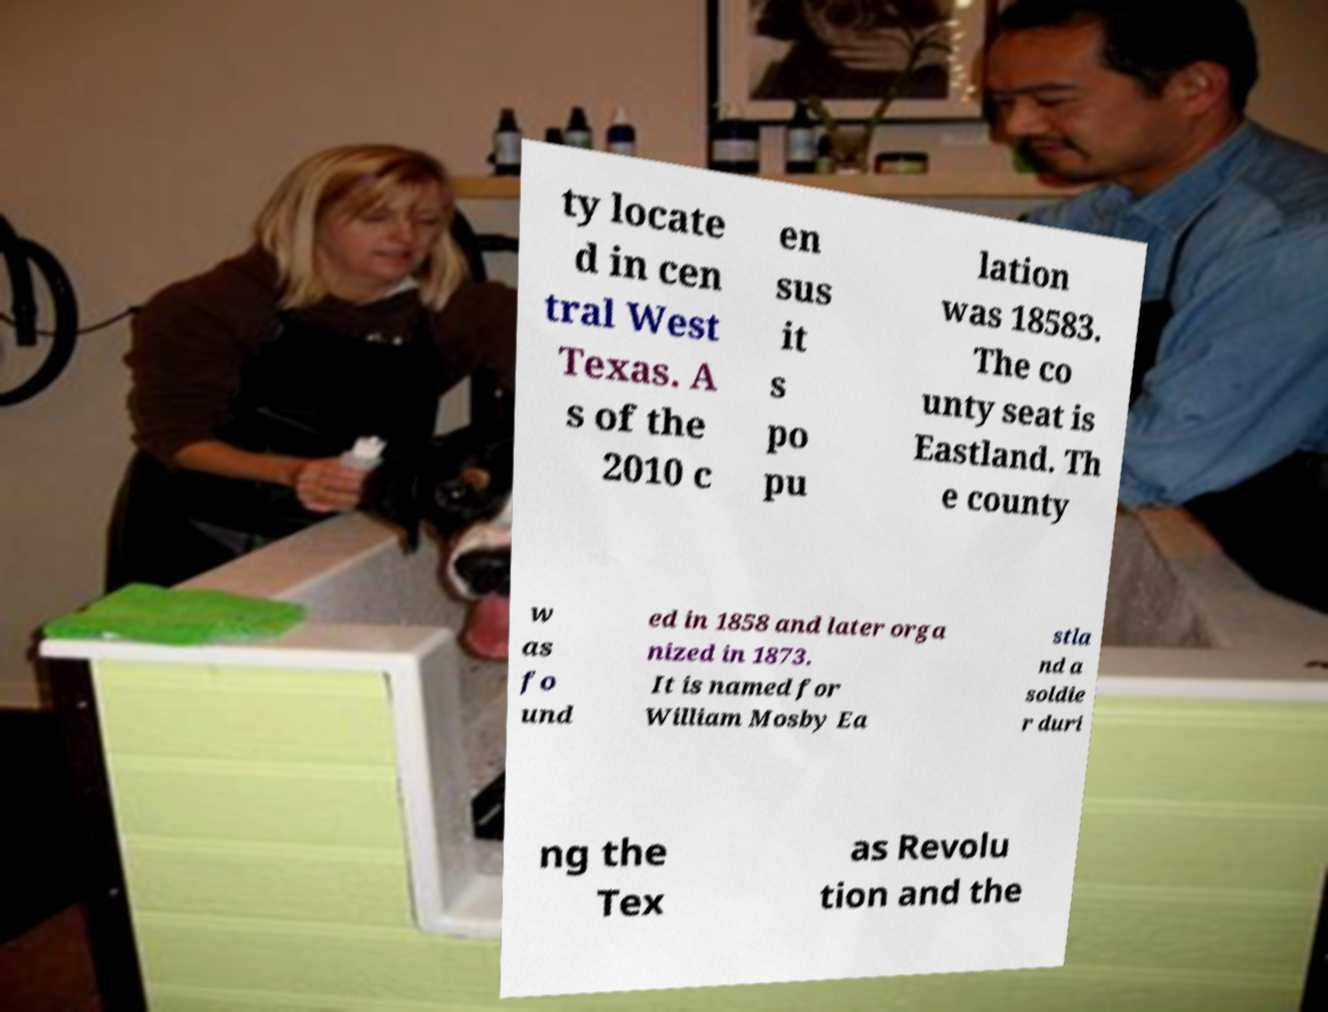Could you extract and type out the text from this image? ty locate d in cen tral West Texas. A s of the 2010 c en sus it s po pu lation was 18583. The co unty seat is Eastland. Th e county w as fo und ed in 1858 and later orga nized in 1873. It is named for William Mosby Ea stla nd a soldie r duri ng the Tex as Revolu tion and the 